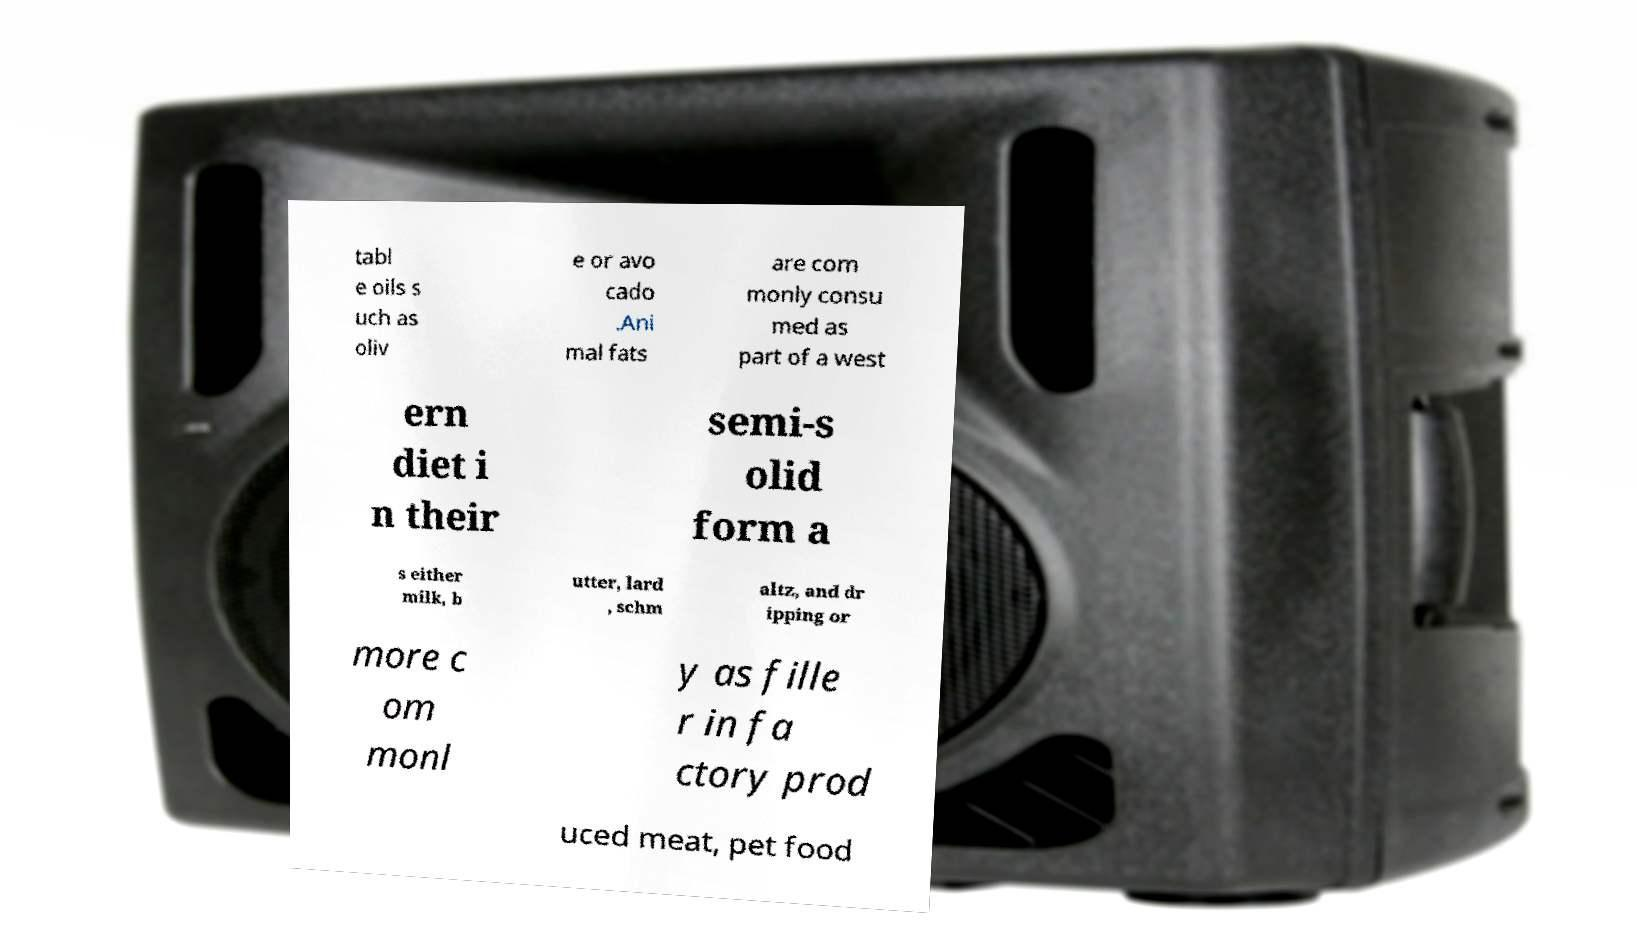Could you extract and type out the text from this image? tabl e oils s uch as oliv e or avo cado .Ani mal fats are com monly consu med as part of a west ern diet i n their semi-s olid form a s either milk, b utter, lard , schm altz, and dr ipping or more c om monl y as fille r in fa ctory prod uced meat, pet food 